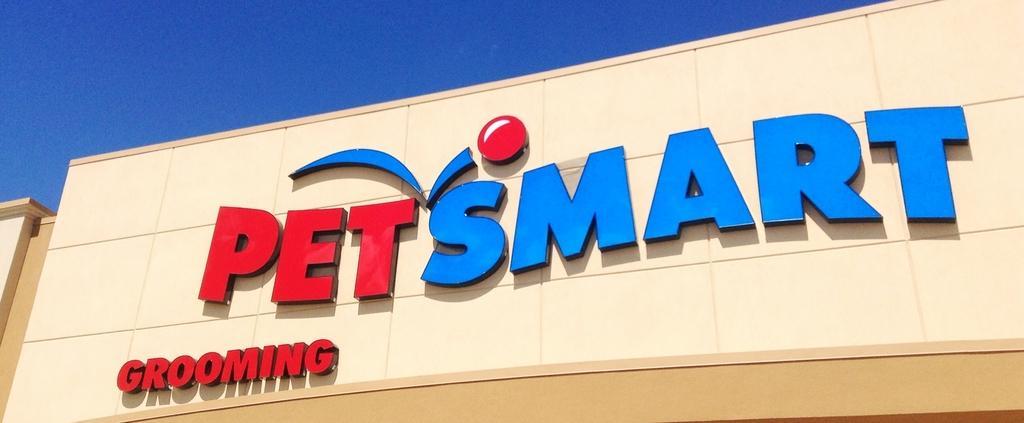How would you summarize this image in a sentence or two? In this picture there is a poster in the center of the image, on which it is written as pets mart. 